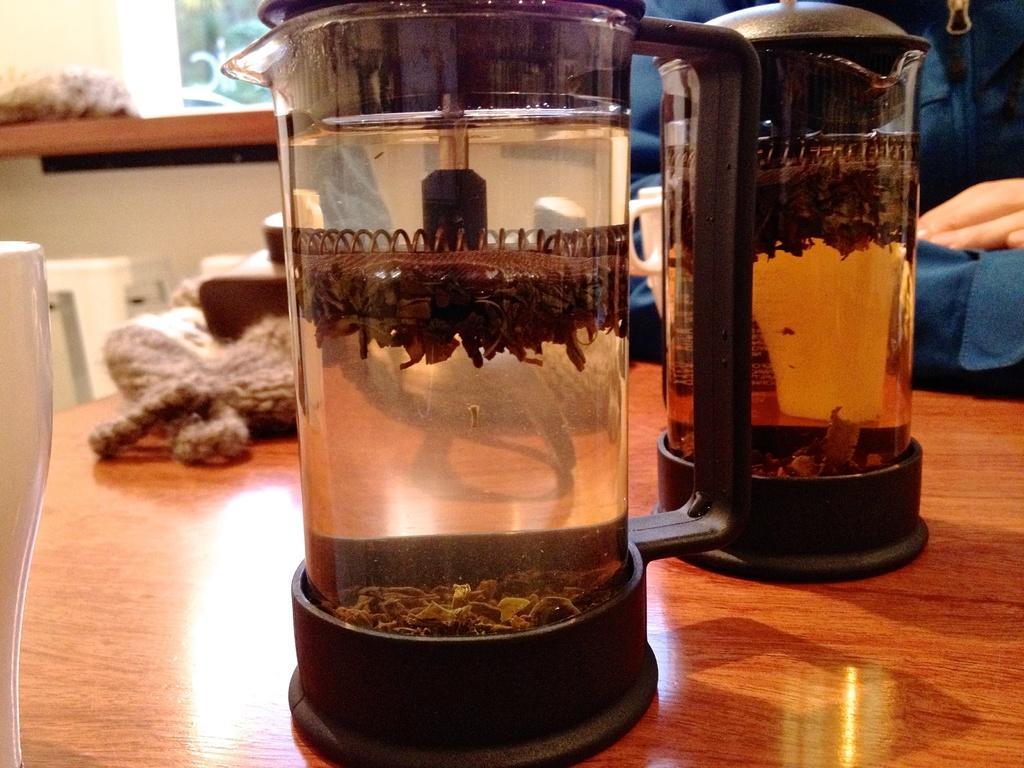Please provide a concise description of this image. In this image in front there are two jars. Inside the jars there is water and there are some objects. Beside the jars there are a few objects on the table. In front of the table there is a chair. There is a person. In the background of the image there is some object on the platform. 